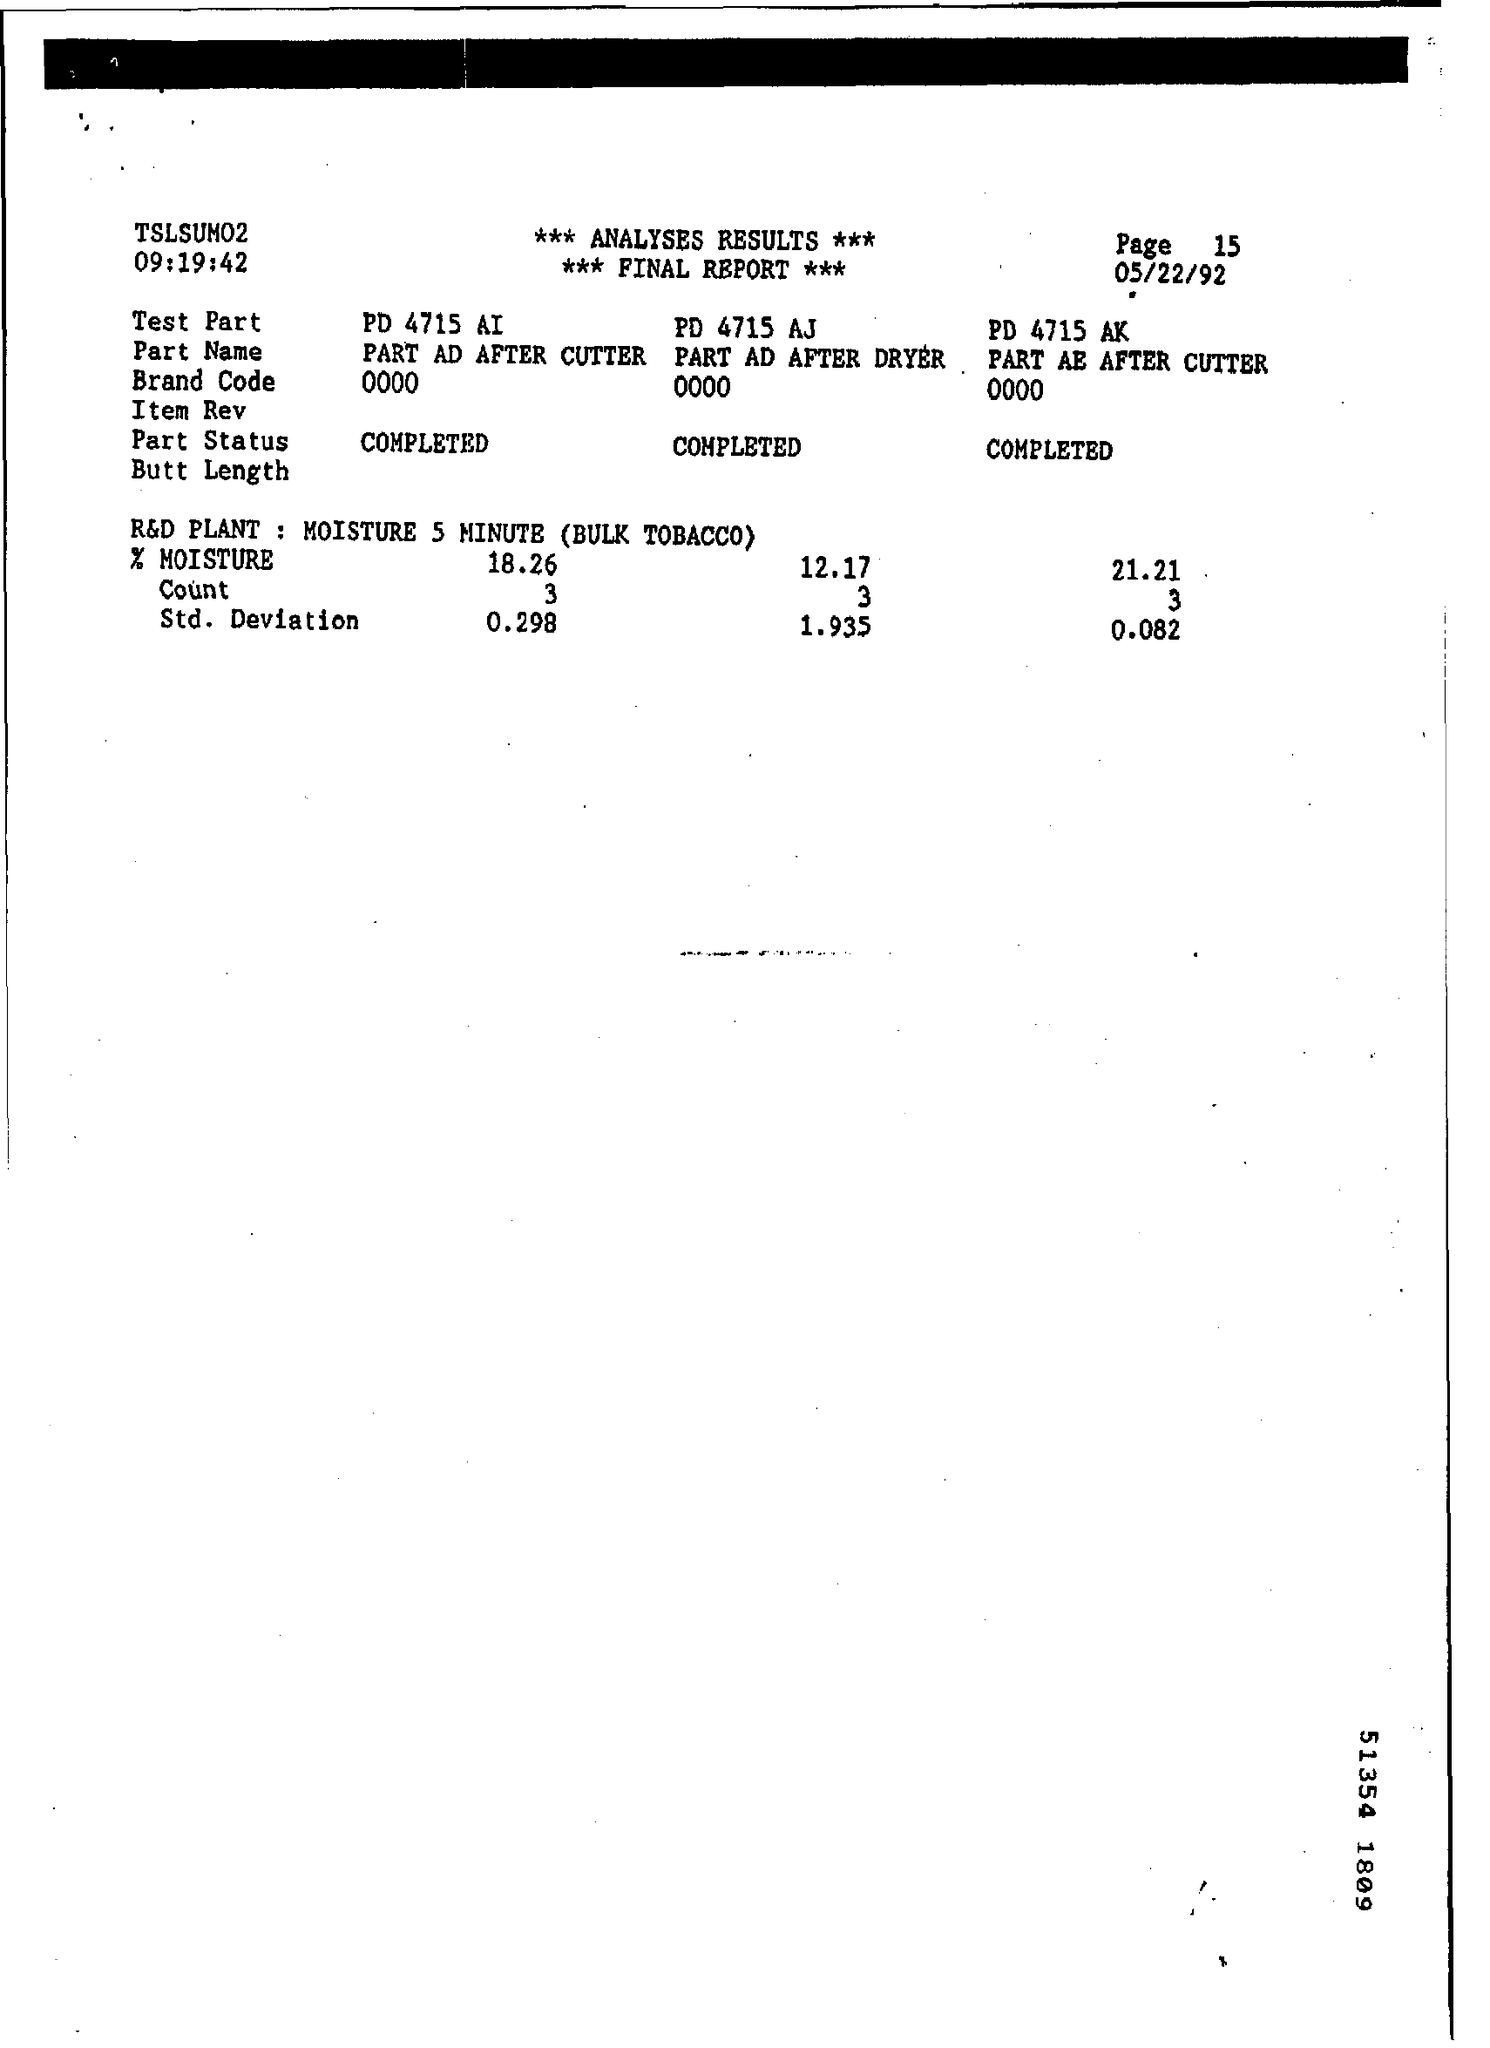What's the Brand code?
Your response must be concise. 0000. What is the Status of Analysis?
Make the answer very short. COMPLETED. What is the Test Part for PART AE AFTER CUTTER?
Your response must be concise. PD 4715 AK. Whats the Std. Deviation of PD 4715 AJ?
Your response must be concise. 1.935. 